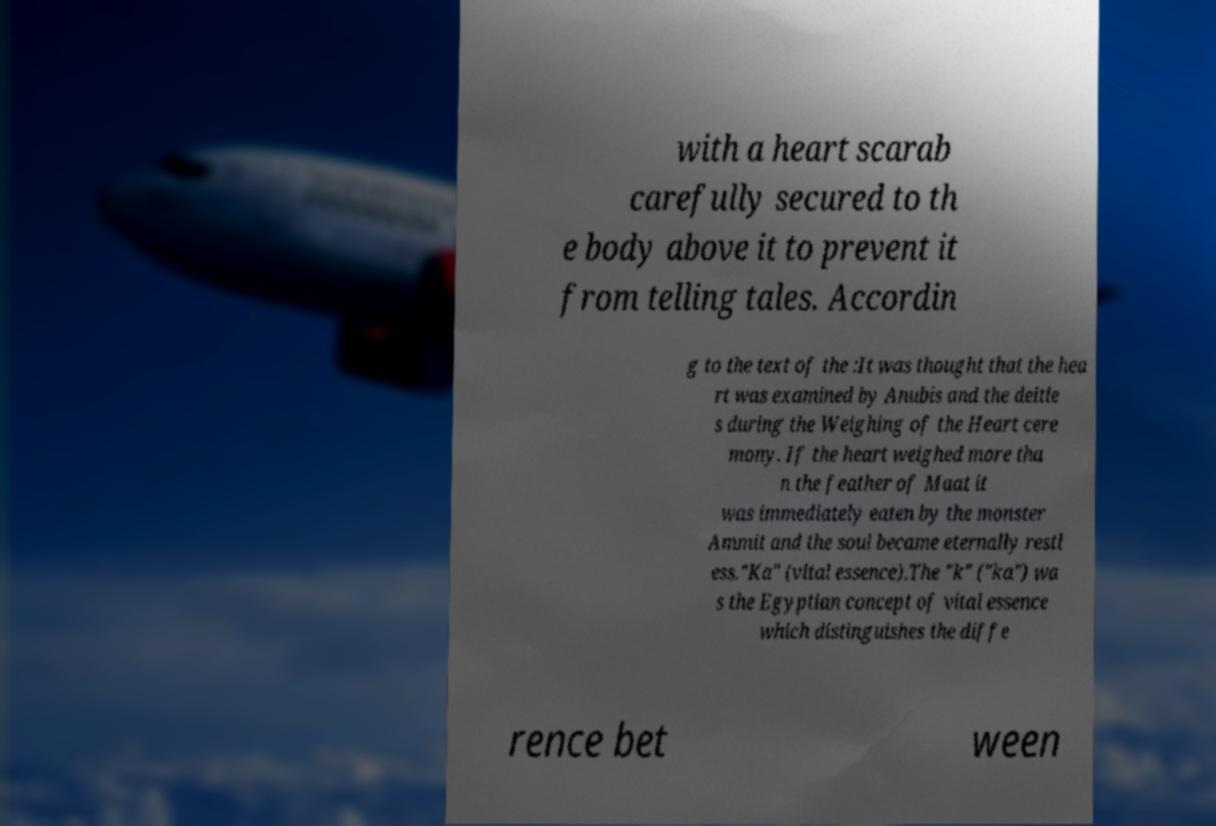Could you assist in decoding the text presented in this image and type it out clearly? with a heart scarab carefully secured to th e body above it to prevent it from telling tales. Accordin g to the text of the :It was thought that the hea rt was examined by Anubis and the deitie s during the Weighing of the Heart cere mony. If the heart weighed more tha n the feather of Maat it was immediately eaten by the monster Ammit and the soul became eternally restl ess."Ka" (vital essence).The "k" ("ka") wa s the Egyptian concept of vital essence which distinguishes the diffe rence bet ween 